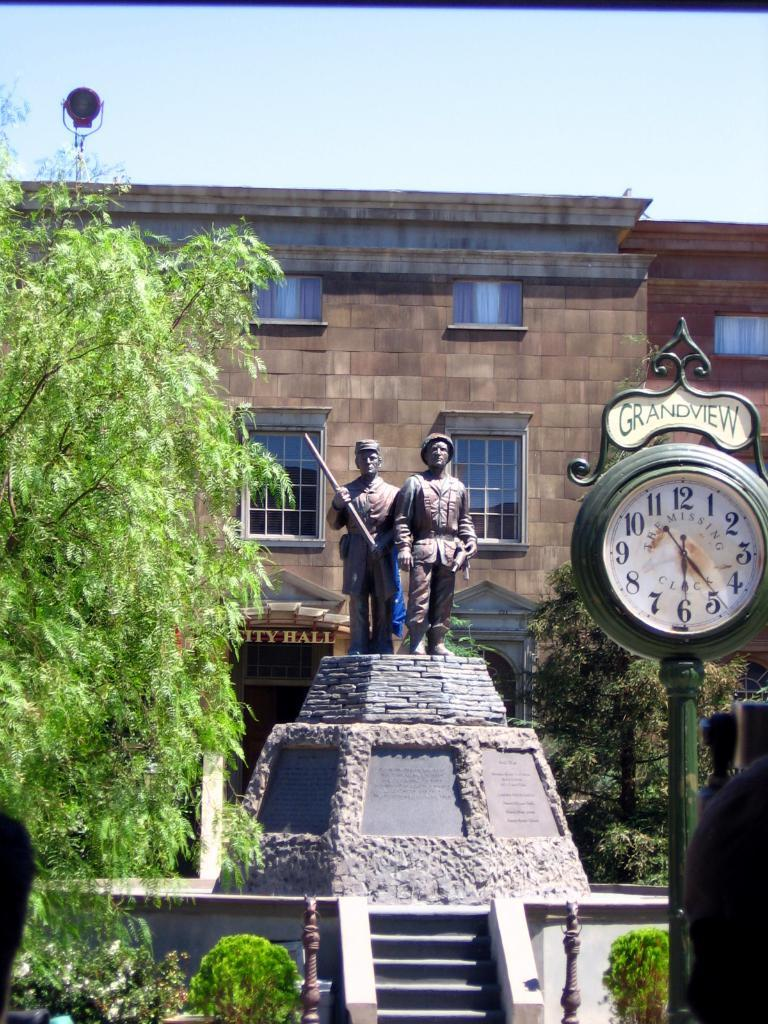<image>
Provide a brief description of the given image. the word grandview is on the sign above the clock 